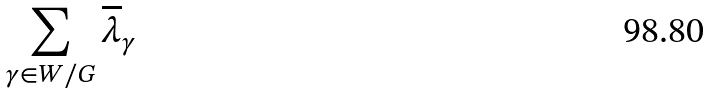Convert formula to latex. <formula><loc_0><loc_0><loc_500><loc_500>\sum _ { \gamma \in W / G } \overline { \lambda } _ { \gamma }</formula> 